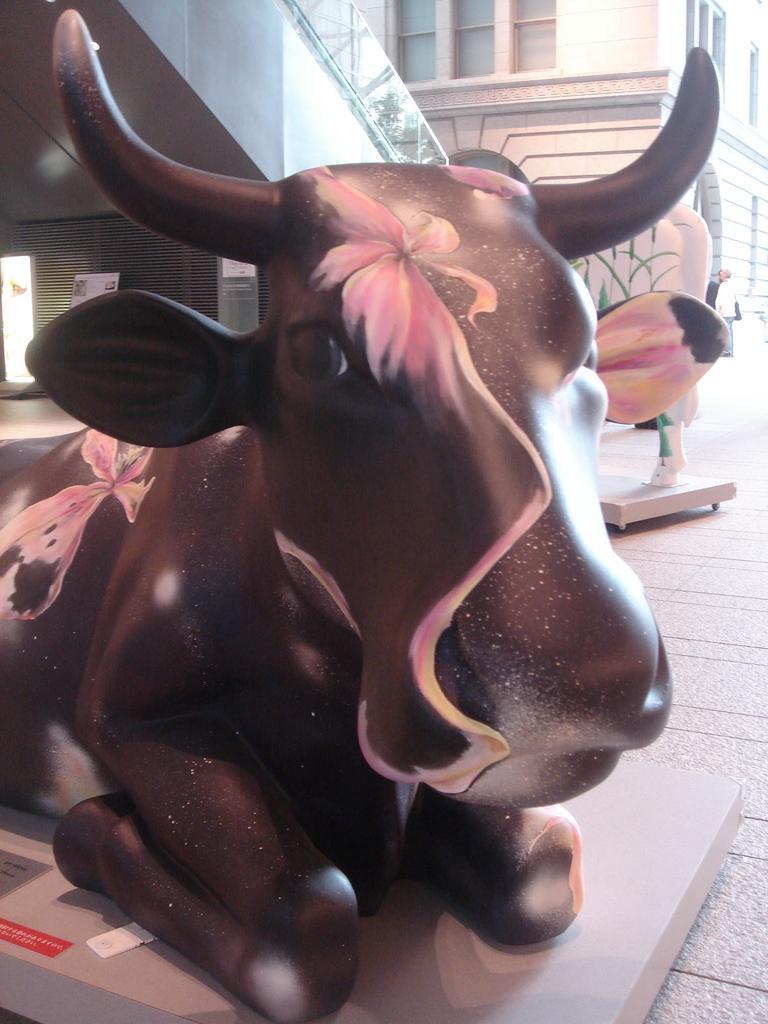Please provide a concise description of this image. In this image there is a bull statue in the middle. In the background there is a building. 